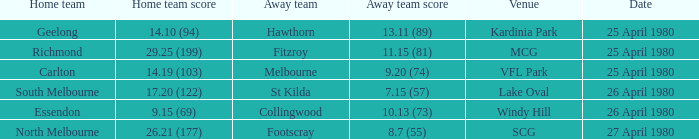What wa the date of the North Melbourne home game? 27 April 1980. 